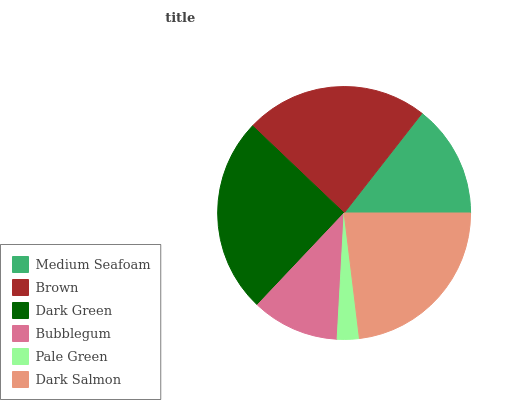Is Pale Green the minimum?
Answer yes or no. Yes. Is Dark Green the maximum?
Answer yes or no. Yes. Is Brown the minimum?
Answer yes or no. No. Is Brown the maximum?
Answer yes or no. No. Is Brown greater than Medium Seafoam?
Answer yes or no. Yes. Is Medium Seafoam less than Brown?
Answer yes or no. Yes. Is Medium Seafoam greater than Brown?
Answer yes or no. No. Is Brown less than Medium Seafoam?
Answer yes or no. No. Is Dark Salmon the high median?
Answer yes or no. Yes. Is Medium Seafoam the low median?
Answer yes or no. Yes. Is Dark Green the high median?
Answer yes or no. No. Is Dark Salmon the low median?
Answer yes or no. No. 